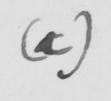Transcribe the text shown in this historical manuscript line. ( c ) 